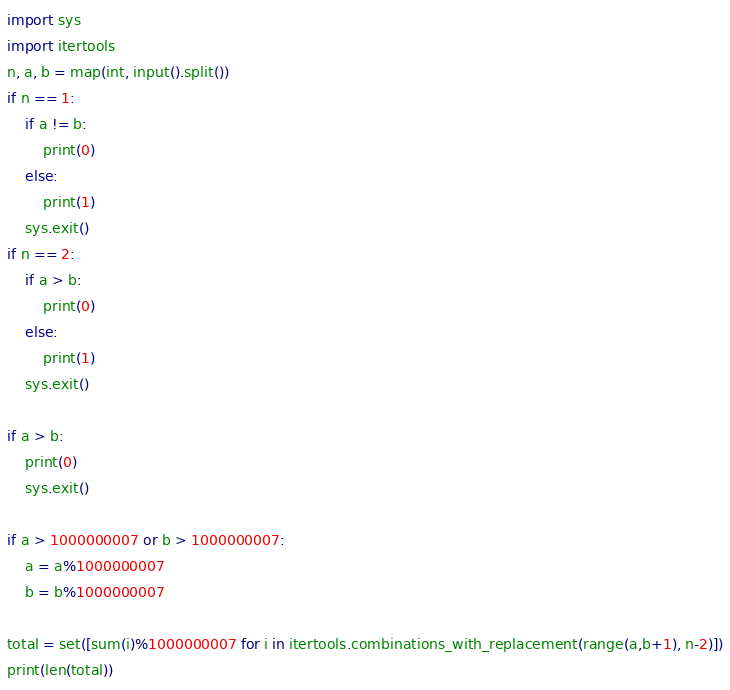Convert code to text. <code><loc_0><loc_0><loc_500><loc_500><_Python_>import sys
import itertools
n, a, b = map(int, input().split())
if n == 1:
    if a != b:
        print(0)
    else:
        print(1)
    sys.exit()
if n == 2:
    if a > b:
        print(0)
    else:
        print(1)
    sys.exit()

if a > b:
    print(0)
    sys.exit()

if a > 1000000007 or b > 1000000007:
    a = a%1000000007
    b = b%1000000007

total = set([sum(i)%1000000007 for i in itertools.combinations_with_replacement(range(a,b+1), n-2)])
print(len(total))</code> 